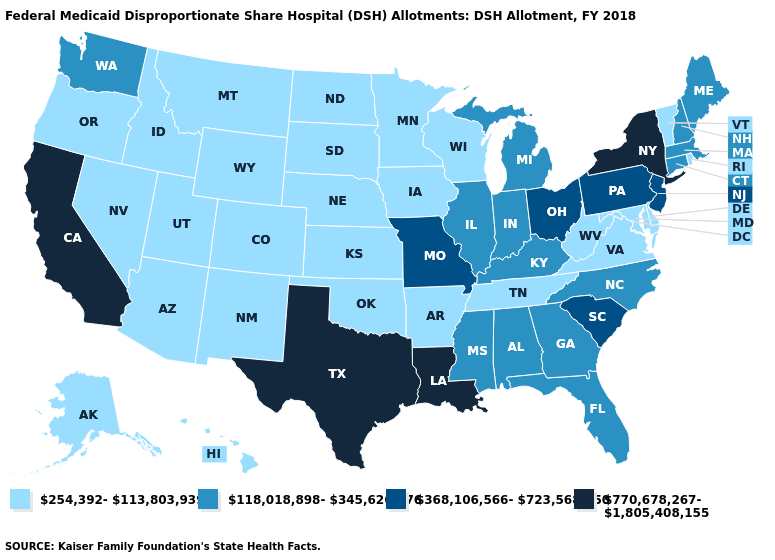What is the value of Kentucky?
Keep it brief. 118,018,898-345,626,776. What is the value of Hawaii?
Give a very brief answer. 254,392-113,803,939. Does Pennsylvania have the lowest value in the Northeast?
Concise answer only. No. What is the lowest value in the USA?
Quick response, please. 254,392-113,803,939. Does Missouri have the same value as Illinois?
Answer briefly. No. Does the map have missing data?
Quick response, please. No. Does Georgia have a higher value than Maine?
Write a very short answer. No. What is the lowest value in the USA?
Answer briefly. 254,392-113,803,939. Among the states that border New Mexico , does Colorado have the lowest value?
Give a very brief answer. Yes. Name the states that have a value in the range 368,106,566-723,568,250?
Answer briefly. Missouri, New Jersey, Ohio, Pennsylvania, South Carolina. What is the lowest value in states that border Delaware?
Answer briefly. 254,392-113,803,939. Does California have the highest value in the West?
Answer briefly. Yes. What is the value of Mississippi?
Write a very short answer. 118,018,898-345,626,776. Name the states that have a value in the range 254,392-113,803,939?
Concise answer only. Alaska, Arizona, Arkansas, Colorado, Delaware, Hawaii, Idaho, Iowa, Kansas, Maryland, Minnesota, Montana, Nebraska, Nevada, New Mexico, North Dakota, Oklahoma, Oregon, Rhode Island, South Dakota, Tennessee, Utah, Vermont, Virginia, West Virginia, Wisconsin, Wyoming. Name the states that have a value in the range 118,018,898-345,626,776?
Quick response, please. Alabama, Connecticut, Florida, Georgia, Illinois, Indiana, Kentucky, Maine, Massachusetts, Michigan, Mississippi, New Hampshire, North Carolina, Washington. 